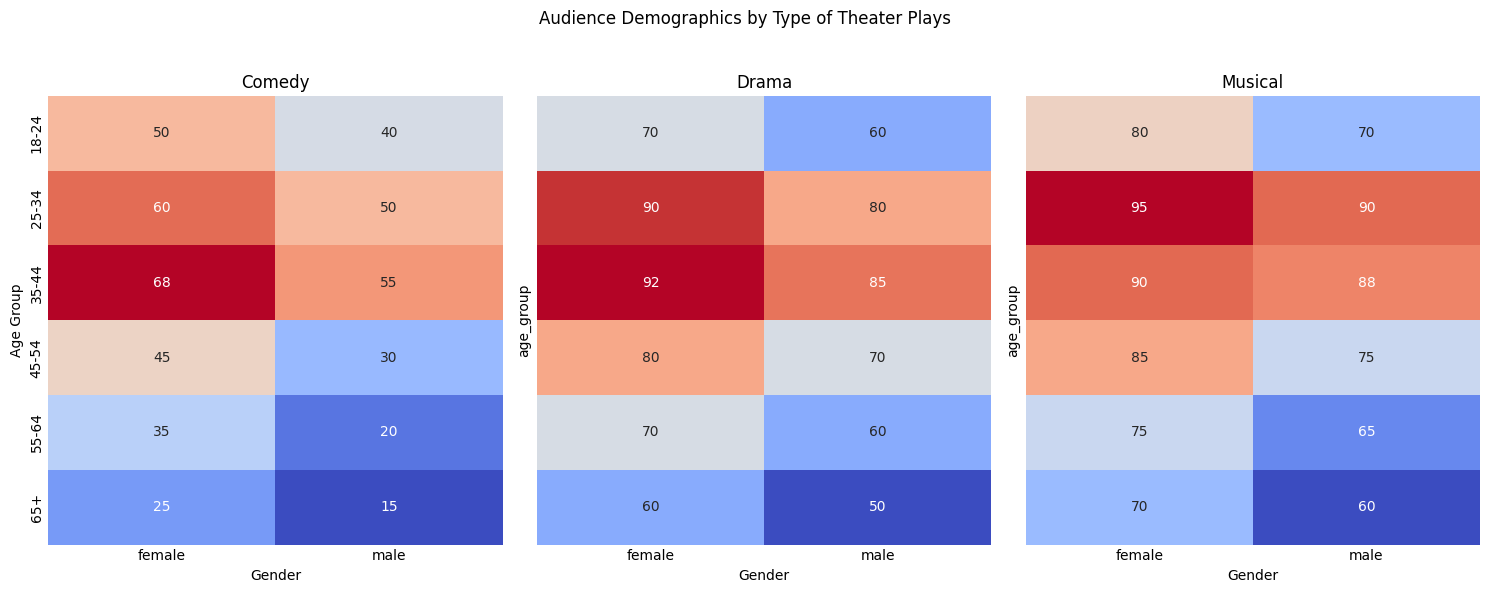What is the age group with the highest number of female audience in Comedy plays? Look at the "Comedy" heatmap and find the highest value in the female column. The highest value is 68 for the 35-44 age group.
Answer: 35-44 Which play type has the highest number of viewers of the age group 18-24 male? Check the values for the male 18-24 row across all heatmaps. For Comedy, the value is 40; for Drama, it is 60; and for Musical, it is 70. The highest value is in Musical.
Answer: Musical How does the number of female viewers in Drama compare between the age groups 25-34 and 35-44? For Drama, in the "female" column, the 25-34 age group has a value of 90 and the 35-44 age group has a value of 92. Compare these values.
Answer: 92 > 90 What is the sum of the male audience for the 45-54 age group across all play types? Sum the values for the 45-54 age group in the male column across all heatmaps: 30 (Comedy) + 70 (Drama) + 75 (Musical).
Answer: 175 What is the total audience in the 18-24 age group for Drama plays? Sum the male and female values for the 18-24 age group in the Drama heatmap: 60 (male) + 70 (female).
Answer: 130 Does the 25-34 age group have a higher male or female audience for Comedy plays? For the 25-34 age group in the Comedy heatmap, compare the male and female values: 50 (male) vs 60 (female).
Answer: Female What is the average number of female audiences for Comedy plays across all age groups? Sum the female values for Comedy: 50 + 60 + 68 + 45 + 35 + 25 = 283. There are 6 age groups, so the average is 283 / 6.
Answer: 47.17 